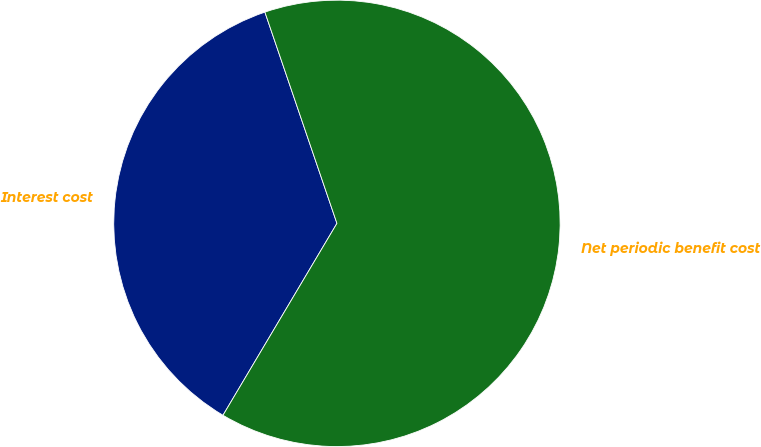<chart> <loc_0><loc_0><loc_500><loc_500><pie_chart><fcel>Interest cost<fcel>Net periodic benefit cost<nl><fcel>36.24%<fcel>63.76%<nl></chart> 